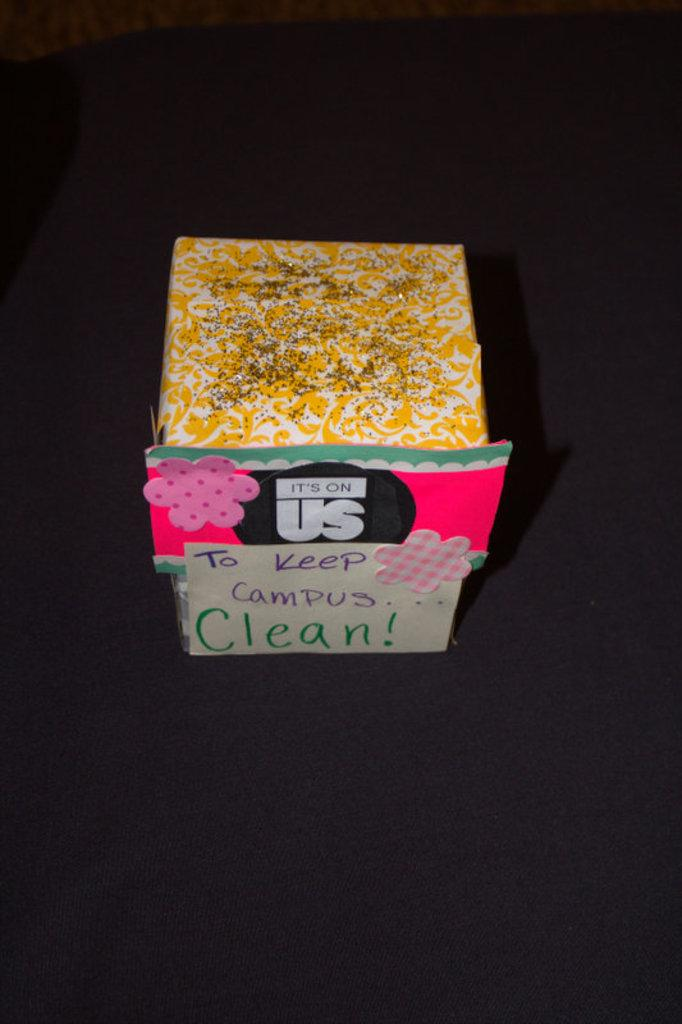<image>
Write a terse but informative summary of the picture. "TO Keep Campus CLean" sticker on a box on top of a surface. 